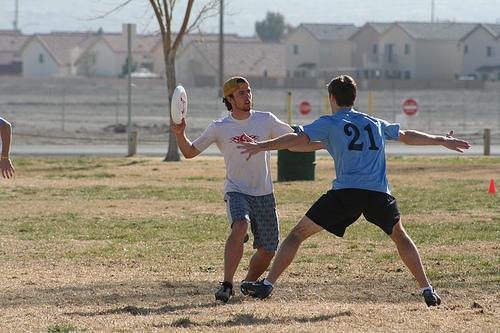What is the color of his shirt?
Answer briefly. Blue. How many white shirts are there?
Give a very brief answer. 1. What game is been played?
Write a very short answer. Frisbee. What kind of pants is the man wearing in the back?
Be succinct. Shorts. Is the man in blue acting as umpire?
Be succinct. No. What are these men playing?
Give a very brief answer. Frisbee. What color is the man's hat?
Write a very short answer. Yellow. What is the player's number in the blue shirt?
Answer briefly. 21. What number is on the jersey?
Write a very short answer. 21. What is he holding?
Give a very brief answer. Frisbee. What sport is he playing?
Be succinct. Frisbee. What are they doing?
Write a very short answer. Playing frisbee. Does the person holding the frisbee need help?
Concise answer only. No. 